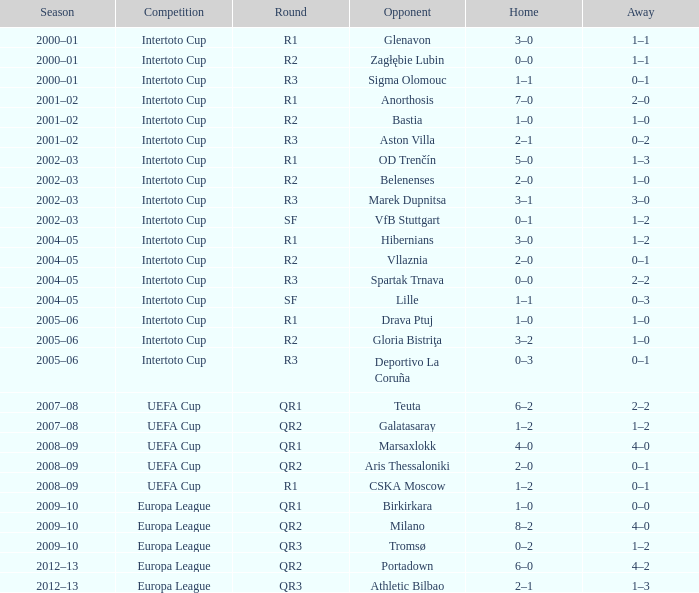What is the home team's score when facing marek dupnitsa as the opposing team? 3–1. 